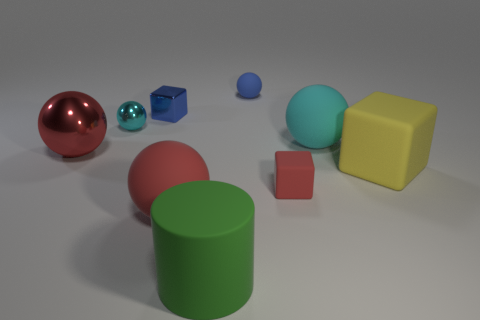Can you describe the lighting and shadows in the scene? The lighting in the scene comes from what appears to be a high, diffused light source, creating soft shadows. The objects have shadows that extend towards the right, indicating the light source is to the left side of the frame, although slightly in front of the objects casting a light diffuse shadow on the ground. 